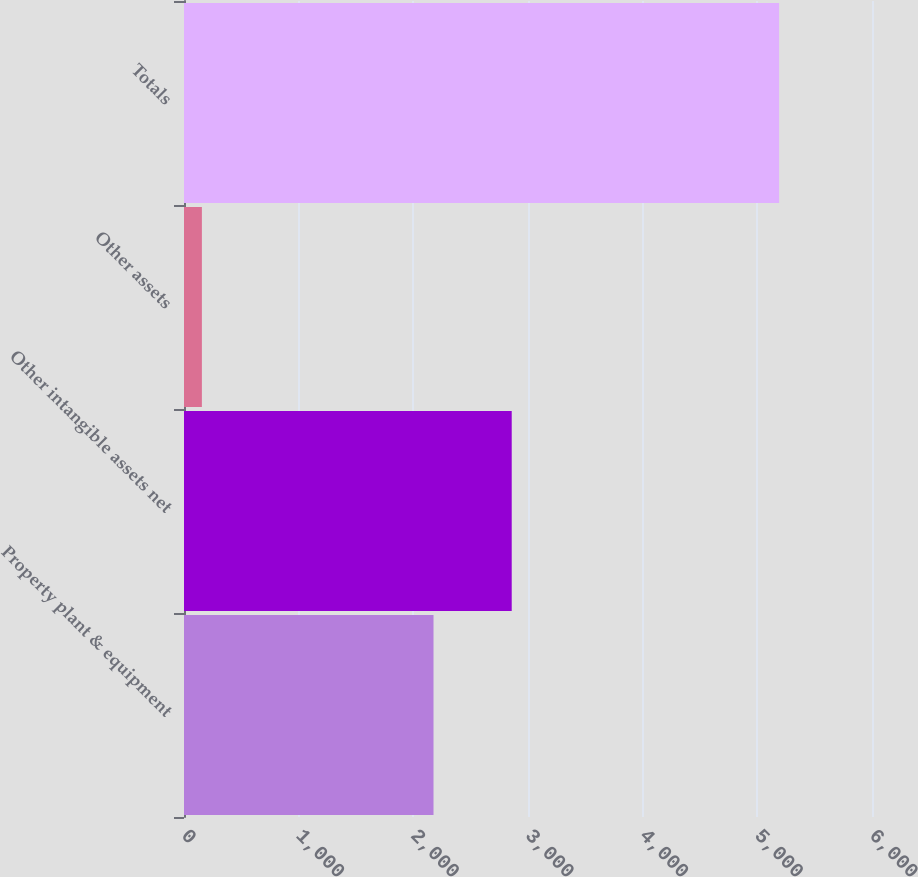Convert chart to OTSL. <chart><loc_0><loc_0><loc_500><loc_500><bar_chart><fcel>Property plant & equipment<fcel>Other intangible assets net<fcel>Other assets<fcel>Totals<nl><fcel>2176<fcel>2858<fcel>156<fcel>5190<nl></chart> 